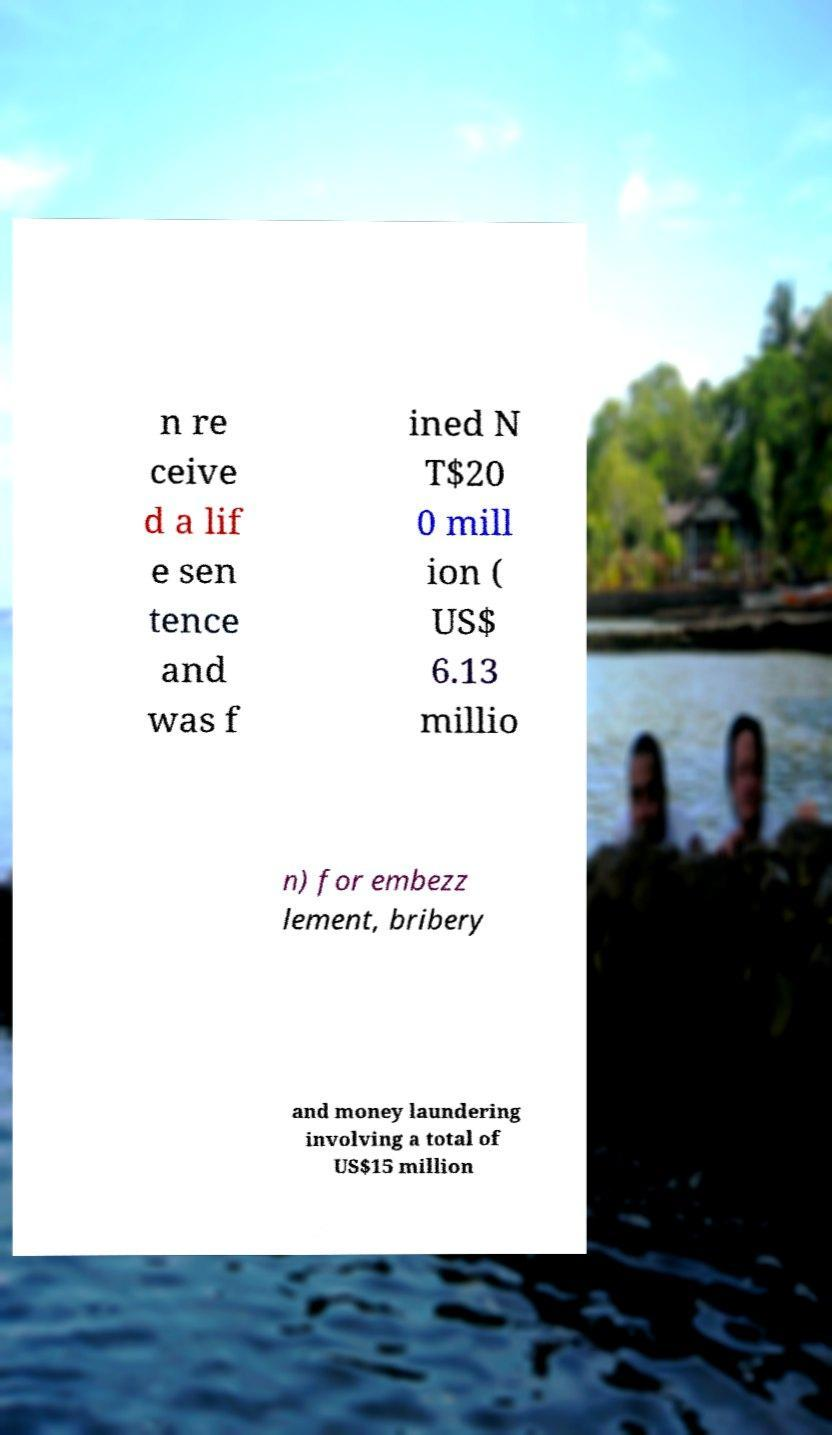Can you read and provide the text displayed in the image?This photo seems to have some interesting text. Can you extract and type it out for me? n re ceive d a lif e sen tence and was f ined N T$20 0 mill ion ( US$ 6.13 millio n) for embezz lement, bribery and money laundering involving a total of US$15 million 